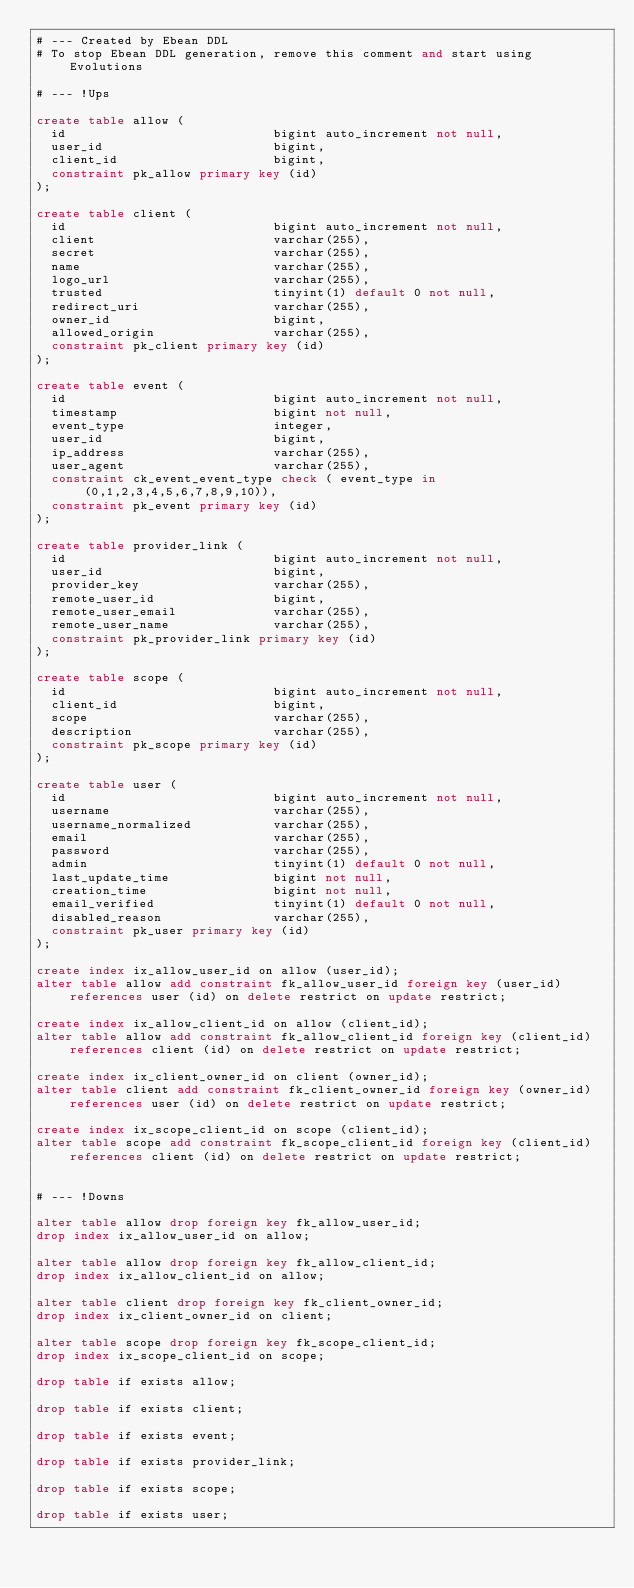Convert code to text. <code><loc_0><loc_0><loc_500><loc_500><_SQL_># --- Created by Ebean DDL
# To stop Ebean DDL generation, remove this comment and start using Evolutions

# --- !Ups

create table allow (
  id                            bigint auto_increment not null,
  user_id                       bigint,
  client_id                     bigint,
  constraint pk_allow primary key (id)
);

create table client (
  id                            bigint auto_increment not null,
  client                        varchar(255),
  secret                        varchar(255),
  name                          varchar(255),
  logo_url                      varchar(255),
  trusted                       tinyint(1) default 0 not null,
  redirect_uri                  varchar(255),
  owner_id                      bigint,
  allowed_origin                varchar(255),
  constraint pk_client primary key (id)
);

create table event (
  id                            bigint auto_increment not null,
  timestamp                     bigint not null,
  event_type                    integer,
  user_id                       bigint,
  ip_address                    varchar(255),
  user_agent                    varchar(255),
  constraint ck_event_event_type check ( event_type in (0,1,2,3,4,5,6,7,8,9,10)),
  constraint pk_event primary key (id)
);

create table provider_link (
  id                            bigint auto_increment not null,
  user_id                       bigint,
  provider_key                  varchar(255),
  remote_user_id                bigint,
  remote_user_email             varchar(255),
  remote_user_name              varchar(255),
  constraint pk_provider_link primary key (id)
);

create table scope (
  id                            bigint auto_increment not null,
  client_id                     bigint,
  scope                         varchar(255),
  description                   varchar(255),
  constraint pk_scope primary key (id)
);

create table user (
  id                            bigint auto_increment not null,
  username                      varchar(255),
  username_normalized           varchar(255),
  email                         varchar(255),
  password                      varchar(255),
  admin                         tinyint(1) default 0 not null,
  last_update_time              bigint not null,
  creation_time                 bigint not null,
  email_verified                tinyint(1) default 0 not null,
  disabled_reason               varchar(255),
  constraint pk_user primary key (id)
);

create index ix_allow_user_id on allow (user_id);
alter table allow add constraint fk_allow_user_id foreign key (user_id) references user (id) on delete restrict on update restrict;

create index ix_allow_client_id on allow (client_id);
alter table allow add constraint fk_allow_client_id foreign key (client_id) references client (id) on delete restrict on update restrict;

create index ix_client_owner_id on client (owner_id);
alter table client add constraint fk_client_owner_id foreign key (owner_id) references user (id) on delete restrict on update restrict;

create index ix_scope_client_id on scope (client_id);
alter table scope add constraint fk_scope_client_id foreign key (client_id) references client (id) on delete restrict on update restrict;


# --- !Downs

alter table allow drop foreign key fk_allow_user_id;
drop index ix_allow_user_id on allow;

alter table allow drop foreign key fk_allow_client_id;
drop index ix_allow_client_id on allow;

alter table client drop foreign key fk_client_owner_id;
drop index ix_client_owner_id on client;

alter table scope drop foreign key fk_scope_client_id;
drop index ix_scope_client_id on scope;

drop table if exists allow;

drop table if exists client;

drop table if exists event;

drop table if exists provider_link;

drop table if exists scope;

drop table if exists user;

</code> 